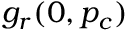Convert formula to latex. <formula><loc_0><loc_0><loc_500><loc_500>g _ { r } ( 0 , p _ { c } )</formula> 